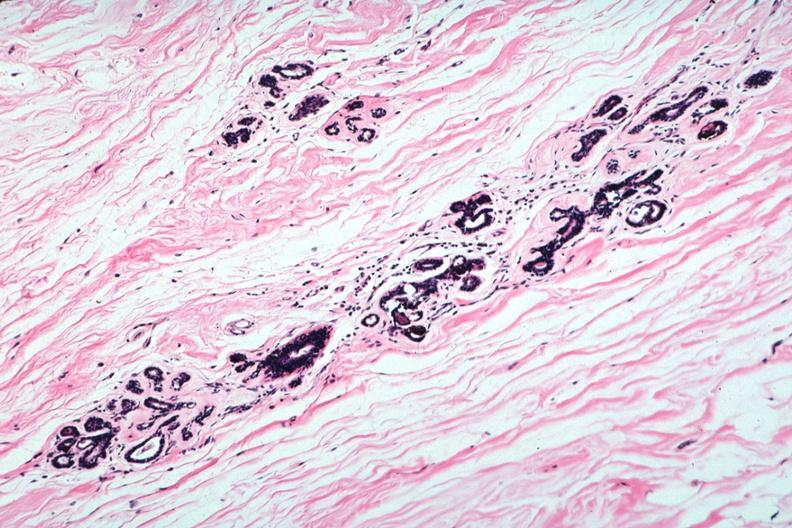what is present?
Answer the question using a single word or phrase. Breast 